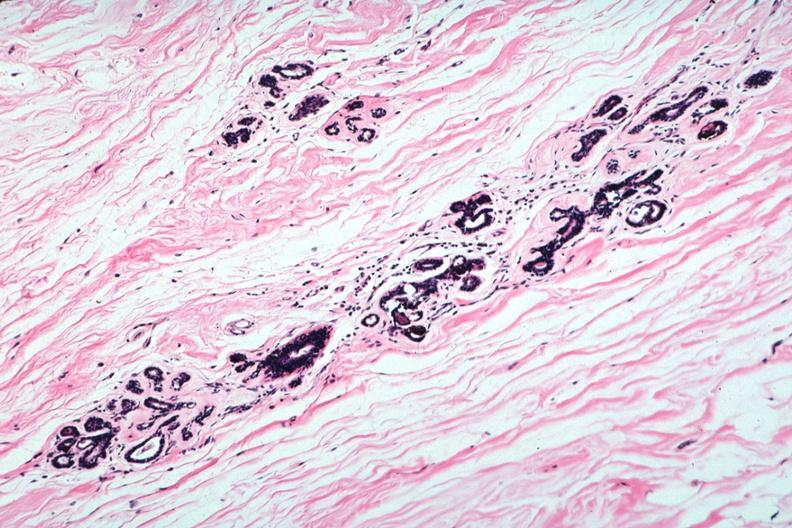what is present?
Answer the question using a single word or phrase. Breast 